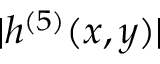Convert formula to latex. <formula><loc_0><loc_0><loc_500><loc_500>| h ^ { ( 5 ) } ( x , y ) |</formula> 